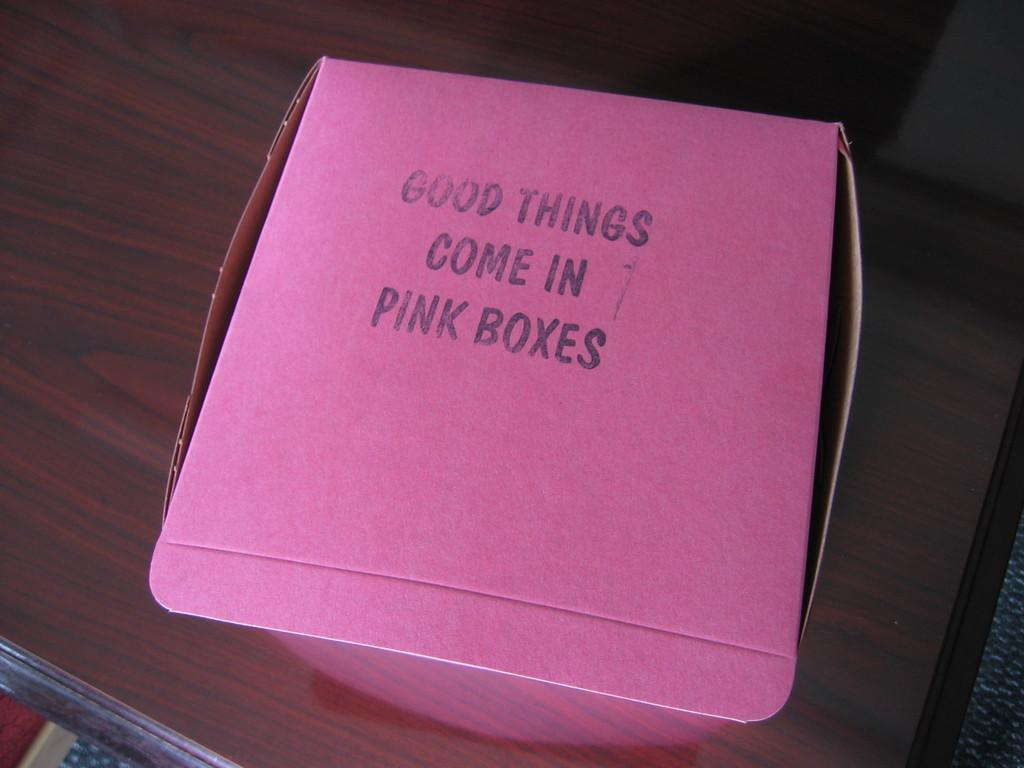<image>
Write a terse but informative summary of the picture. The pink box on the table probably contains something good. 